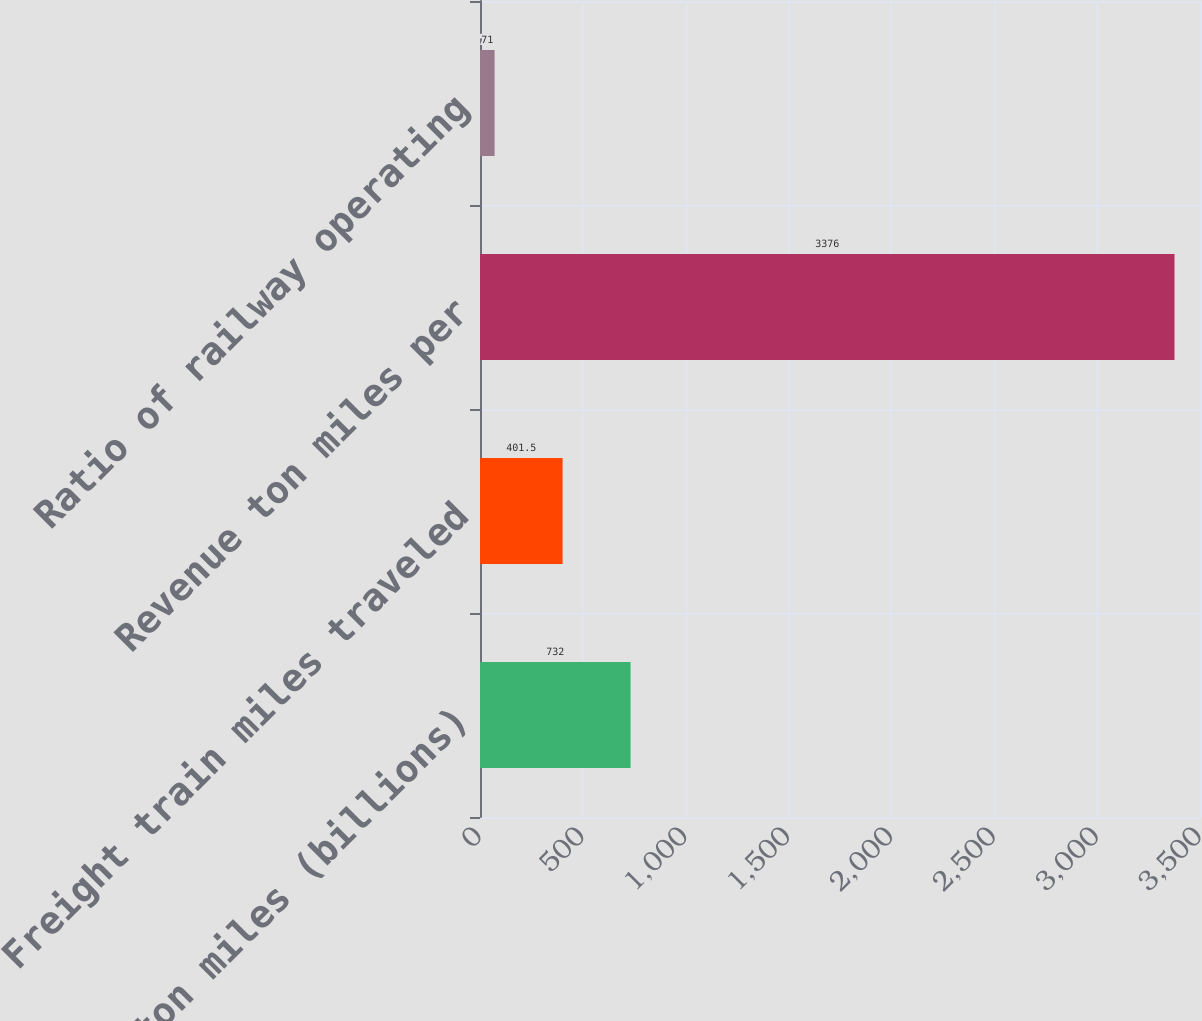Convert chart to OTSL. <chart><loc_0><loc_0><loc_500><loc_500><bar_chart><fcel>Revenue ton miles (billions)<fcel>Freight train miles traveled<fcel>Revenue ton miles per<fcel>Ratio of railway operating<nl><fcel>732<fcel>401.5<fcel>3376<fcel>71<nl></chart> 